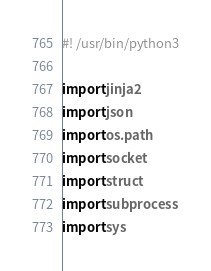Convert code to text. <code><loc_0><loc_0><loc_500><loc_500><_Python_>#! /usr/bin/python3

import jinja2
import json
import os.path
import socket
import struct
import subprocess
import sys

</code> 